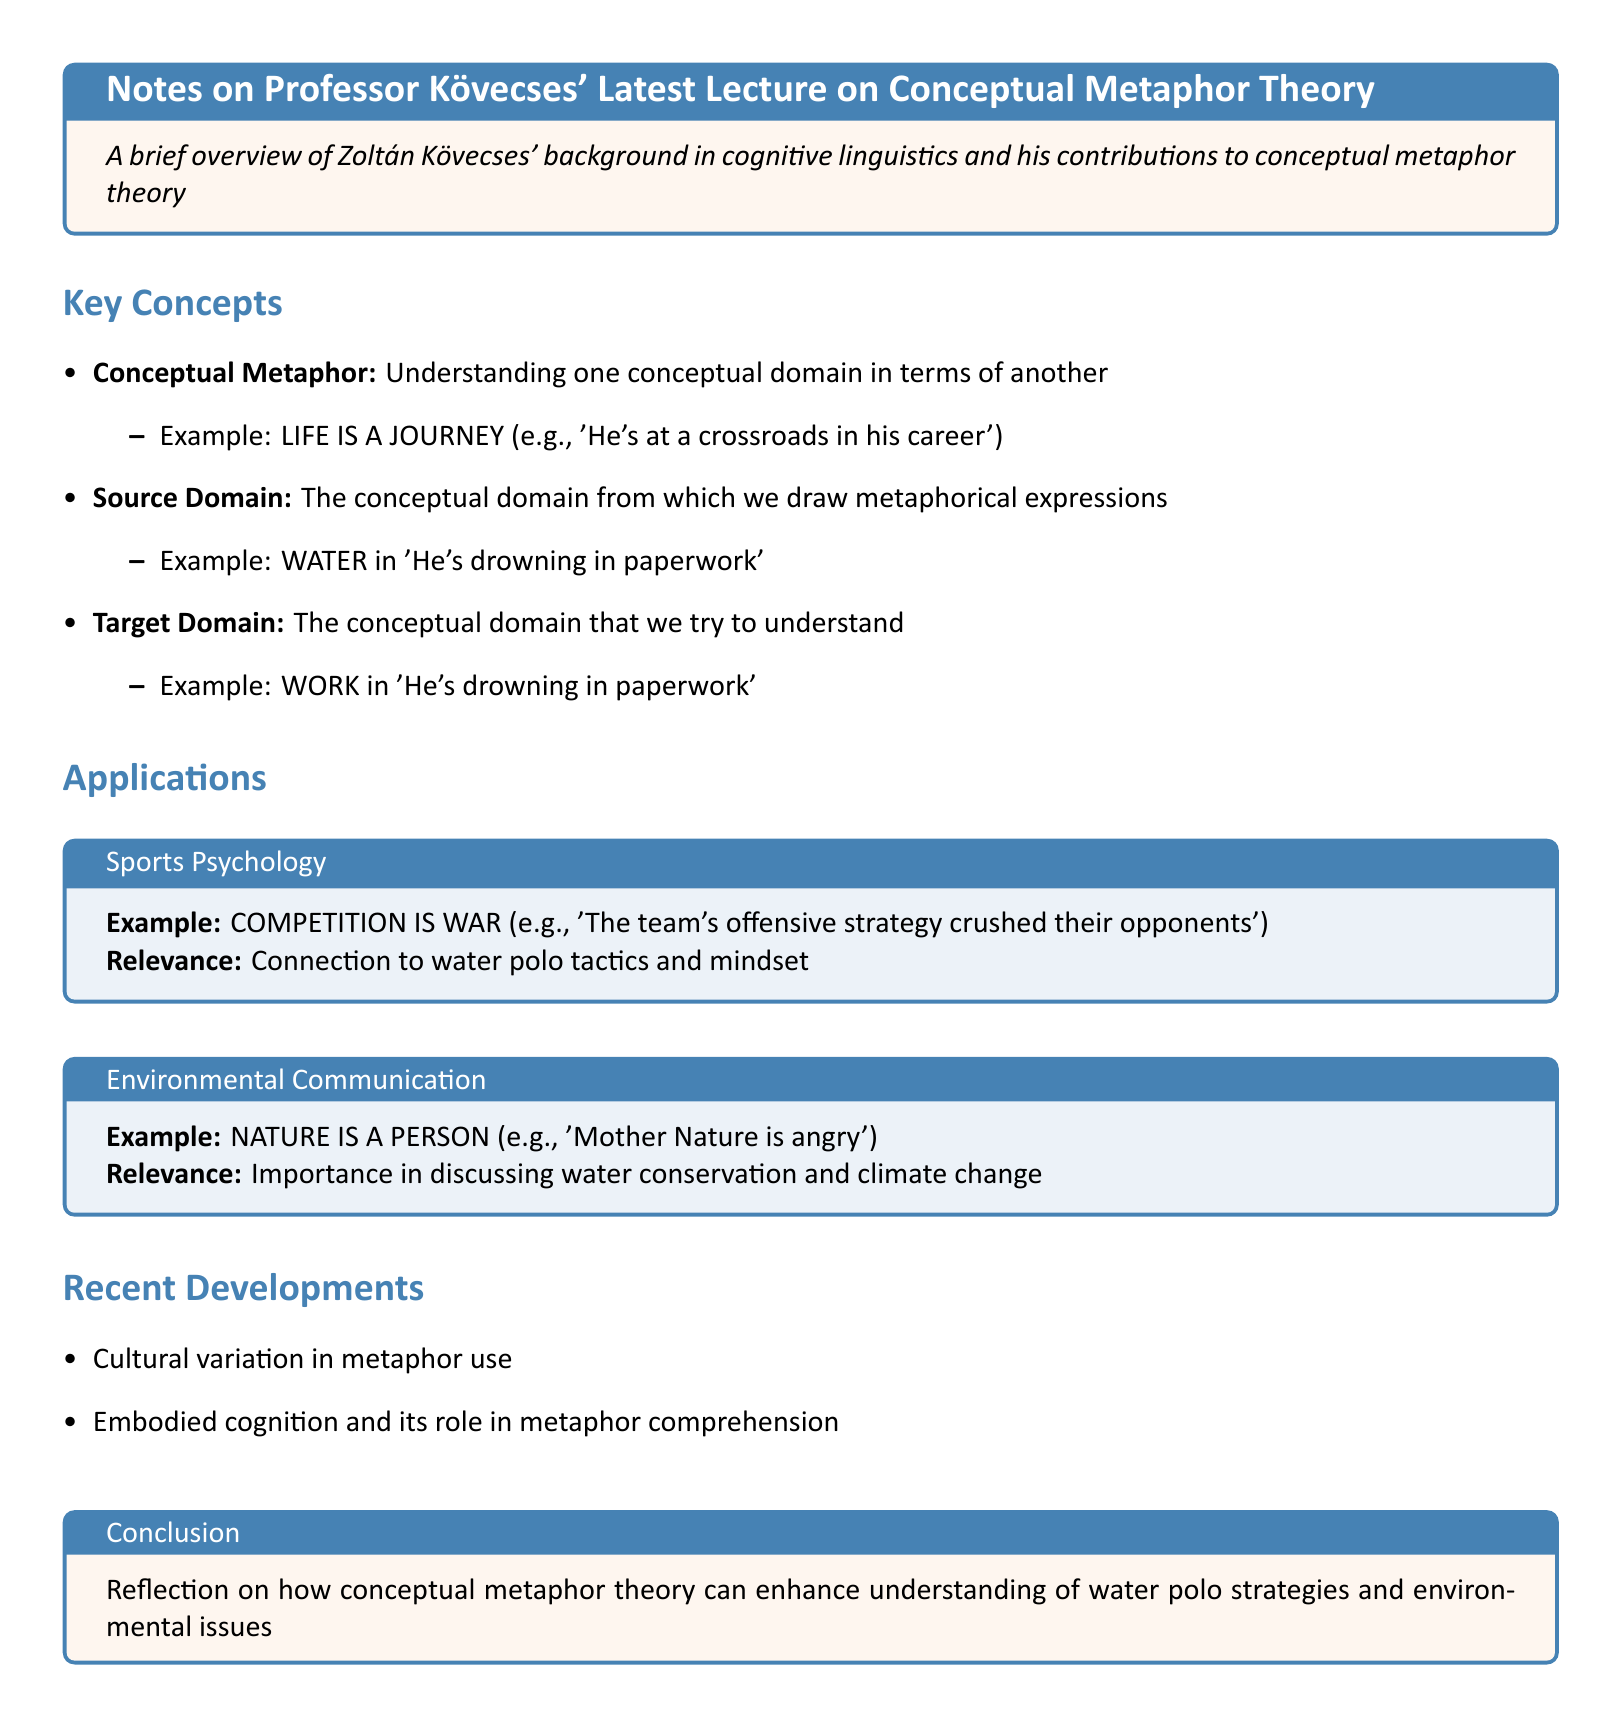What is the title of the document? The title is the main heading of the document that summarizes its content.
Answer: Notes on Professor Kövecses' Latest Lecture on Conceptual Metaphor Theory Who is the author of the lecture discussed in the notes? The author of the lecture is mentioned in the introduction section of the document.
Answer: Zoltán Kövecses What is the example given for the concept "LIFE IS A JOURNEY"? This example helps illustrate the conceptual metaphor definition provided in the document.
Answer: 'He's at a crossroads in his career' In which field is the application "COMPETITION IS WAR" used? The field relates to the context provided for this application in the document.
Answer: Sports Psychology What are the two recent developments mentioned in the document? The recent developments indicate the evolving nature of metaphor theory discussed in the notes.
Answer: Cultural variation in metaphor use, Embodied cognition and its role in metaphor comprehension What is the target domain in the example "He's drowning in paperwork"? The target domain is specified as the conceptual domain that is trying to be understood.
Answer: WORK What is the importance of the metaphor "NATURE IS A PERSON"? The relevance describes how this metaphor is applied in environmental discussions.
Answer: Importance in discussing water conservation and climate change What does the conclusion reflect on? The conclusion summarizes the implications of the conceptual metaphor theory discussed throughout the document.
Answer: How conceptual metaphor theory can enhance understanding of water polo strategies and environmental issues 